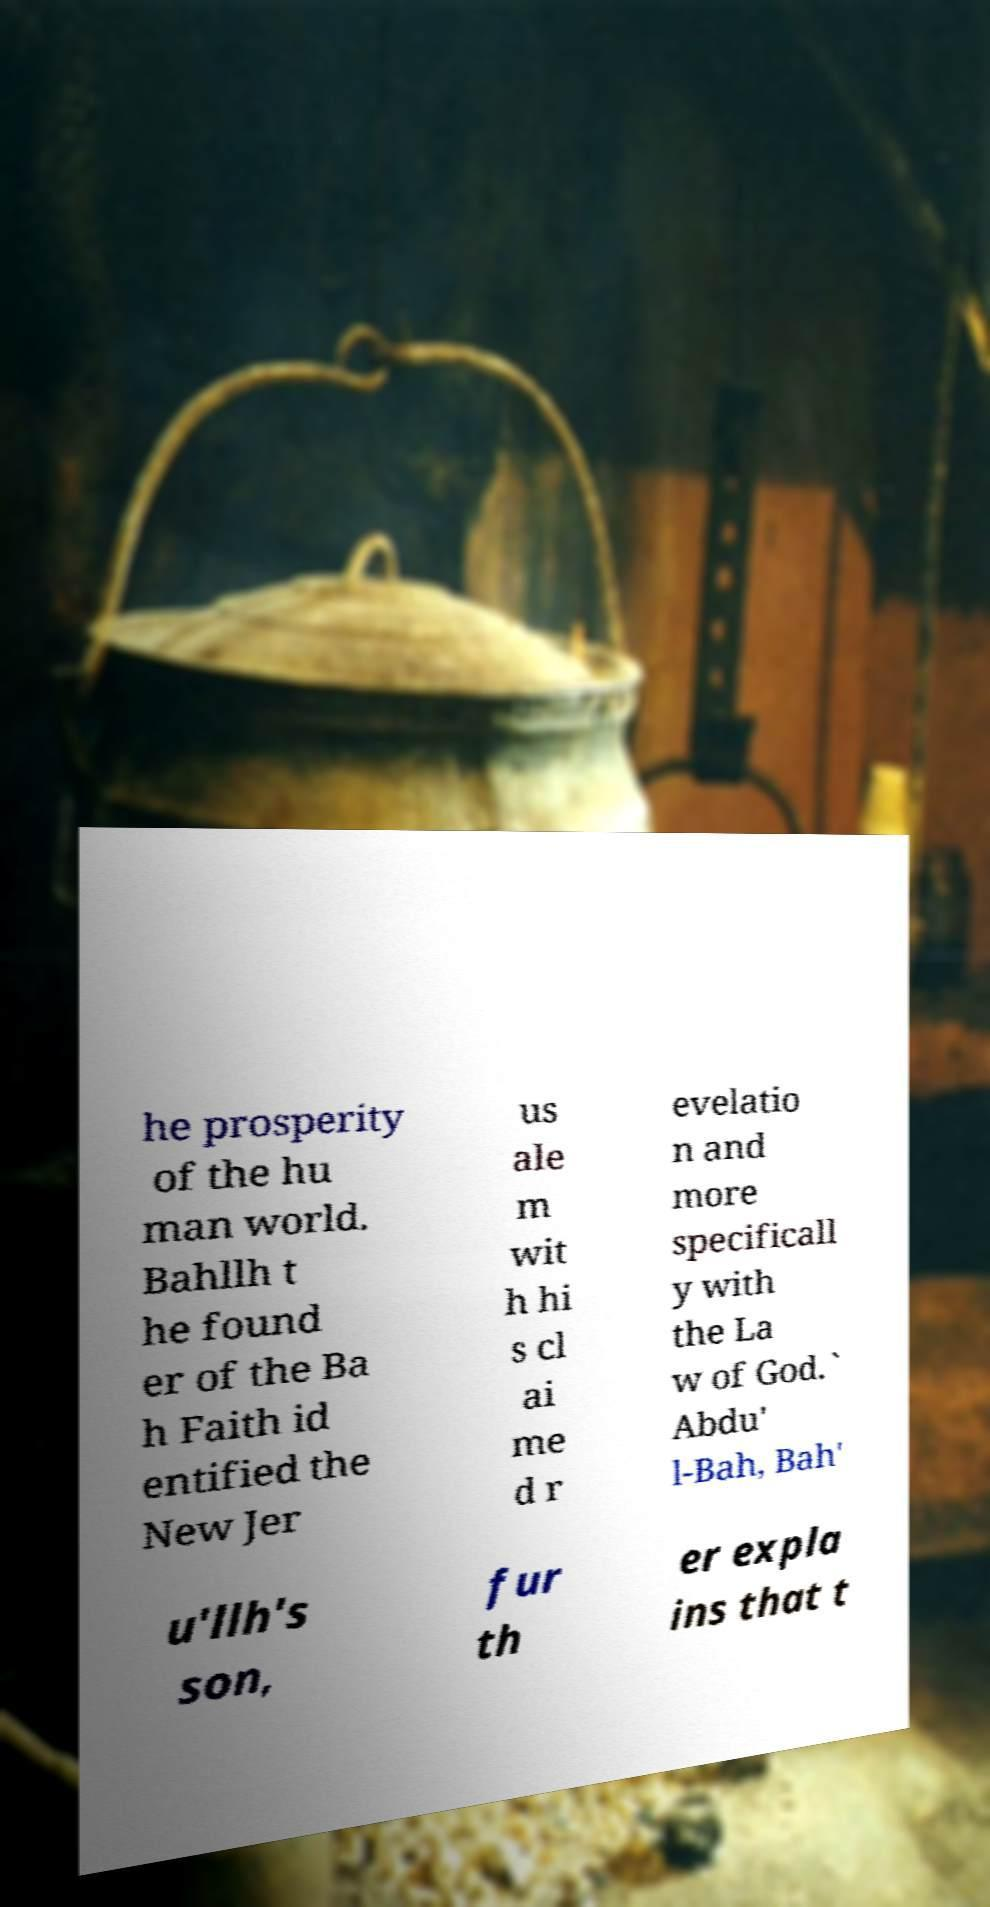I need the written content from this picture converted into text. Can you do that? he prosperity of the hu man world. Bahllh t he found er of the Ba h Faith id entified the New Jer us ale m wit h hi s cl ai me d r evelatio n and more specificall y with the La w of God.` Abdu' l-Bah, Bah' u'llh's son, fur th er expla ins that t 